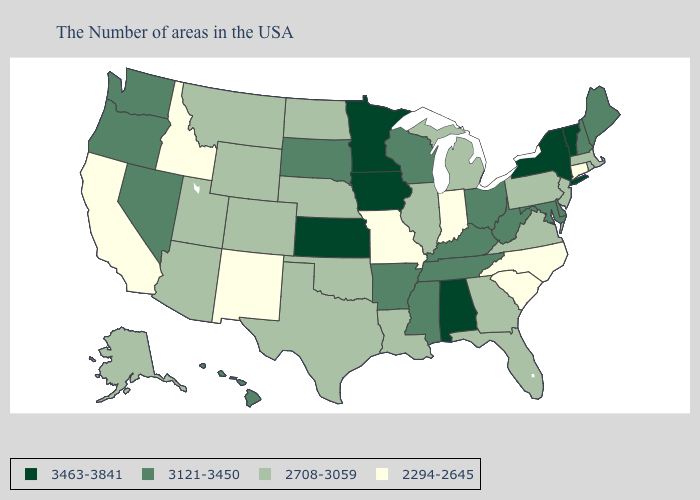What is the value of California?
Quick response, please. 2294-2645. Does the first symbol in the legend represent the smallest category?
Keep it brief. No. Among the states that border Montana , which have the lowest value?
Be succinct. Idaho. Name the states that have a value in the range 2294-2645?
Short answer required. Connecticut, North Carolina, South Carolina, Indiana, Missouri, New Mexico, Idaho, California. Name the states that have a value in the range 3463-3841?
Give a very brief answer. Vermont, New York, Alabama, Minnesota, Iowa, Kansas. What is the value of Mississippi?
Write a very short answer. 3121-3450. Which states have the highest value in the USA?
Keep it brief. Vermont, New York, Alabama, Minnesota, Iowa, Kansas. Among the states that border Connecticut , does New York have the highest value?
Keep it brief. Yes. Name the states that have a value in the range 3463-3841?
Keep it brief. Vermont, New York, Alabama, Minnesota, Iowa, Kansas. What is the lowest value in the USA?
Answer briefly. 2294-2645. What is the value of Maine?
Write a very short answer. 3121-3450. Name the states that have a value in the range 2294-2645?
Write a very short answer. Connecticut, North Carolina, South Carolina, Indiana, Missouri, New Mexico, Idaho, California. What is the value of North Dakota?
Concise answer only. 2708-3059. Does Indiana have the lowest value in the MidWest?
Answer briefly. Yes. Which states have the lowest value in the Northeast?
Answer briefly. Connecticut. 